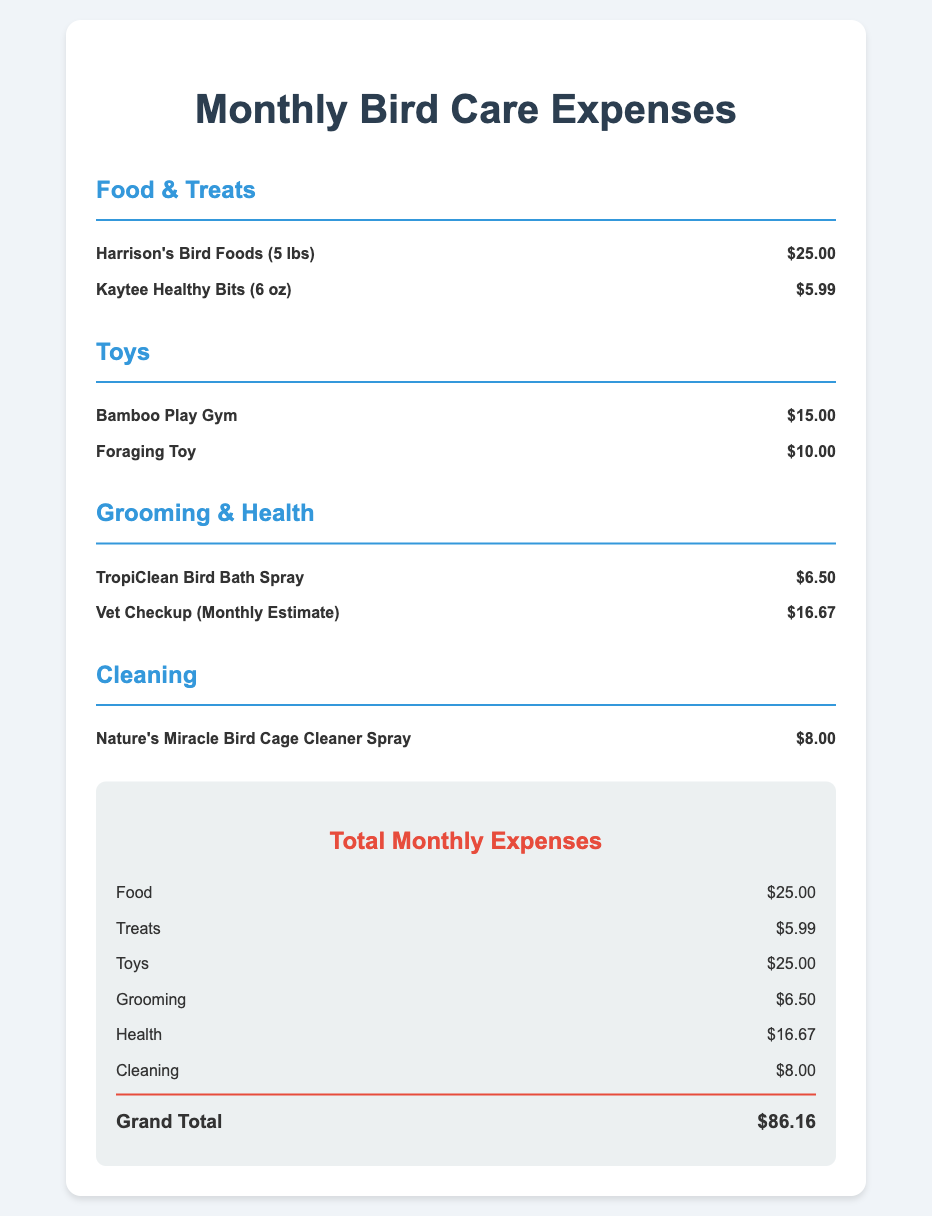what is the total amount spent on food? The total amount spent on food is the sum of the food items listed, which is $25.00 + $5.99 = $30.99.
Answer: $30.99 how much does a vet checkup cost? The vet checkup monthly estimate is listed in the document as $16.67.
Answer: $16.67 what is the cost of the Bamboo Play Gym? The document lists the Bamboo Play Gym as $15.00.
Answer: $15.00 which cleaning product is mentioned? The cleaning product mentioned is Nature's Miracle Bird Cage Cleaner Spray, which costs $8.00.
Answer: Nature's Miracle Bird Cage Cleaner Spray what is the grand total for monthly expenses? The grand total for monthly expenses is calculated from all the expenses listed, which comes to $86.16.
Answer: $86.16 how much was spent on toys? The total for toys is the sum of the toy items listed, which is $15.00 + $10.00 = $25.00.
Answer: $25.00 what is the price of the Harrison's Bird Foods? Harrison's Bird Foods (5 lbs) is priced at $25.00 in the document.
Answer: $25.00 how many types of expenses are listed? The document lists four types of expenses: Food & Treats, Toys, Grooming & Health, and Cleaning.
Answer: Four types what portion of the total expenses is allocated for grooming items? The grooming section includes $6.50 for the bird bath spray and $16.67 for the vet checkup, totaling $23.17 for grooming.
Answer: $23.17 